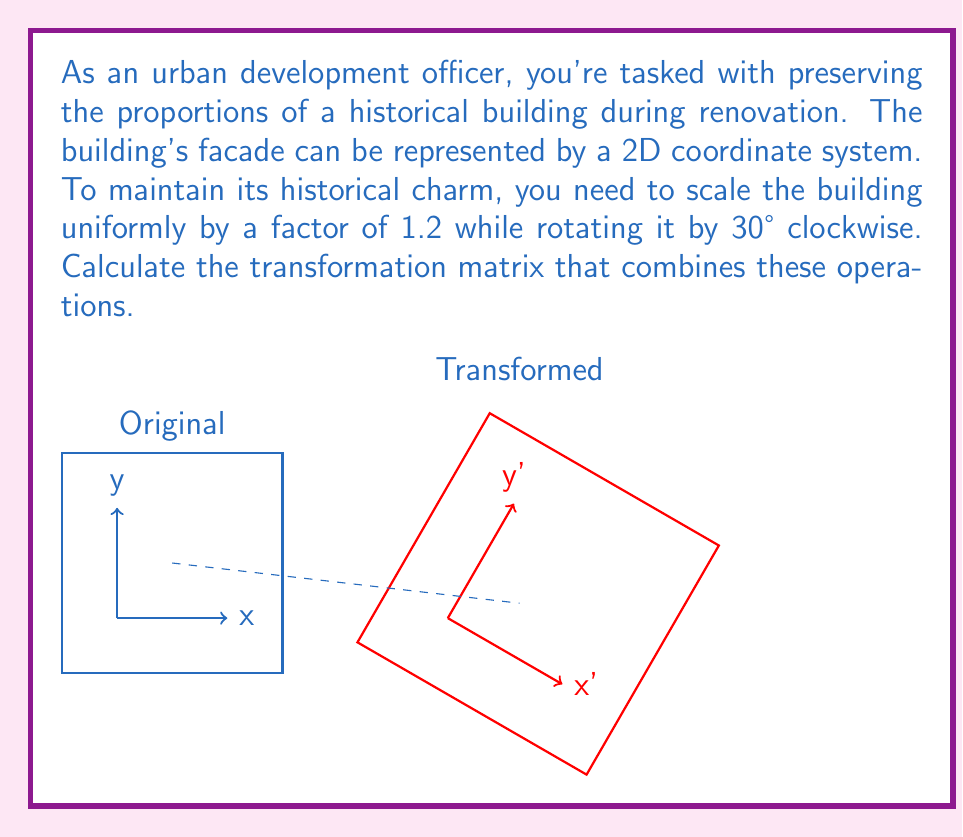Provide a solution to this math problem. To solve this problem, we need to combine two transformations: scaling and rotation. Let's approach this step-by-step:

1) First, let's recall the transformation matrices for scaling and rotation:

   Scaling matrix (by factor k): 
   $$S = \begin{pmatrix} k & 0 \\ 0 & k \end{pmatrix}$$

   Rotation matrix (by angle θ clockwise):
   $$R = \begin{pmatrix} \cos\theta & \sin\theta \\ -\sin\theta & \cos\theta \end{pmatrix}$$

2) In our case, k = 1.2 and θ = 30° = π/6 radians.

3) Let's calculate the scaling matrix:
   $$S = \begin{pmatrix} 1.2 & 0 \\ 0 & 1.2 \end{pmatrix}$$

4) Now, let's calculate the rotation matrix:
   $$R = \begin{pmatrix} \cos(π/6) & \sin(π/6) \\ -\sin(π/6) & \cos(π/6) \end{pmatrix}
   = \begin{pmatrix} \sqrt{3}/2 & 1/2 \\ -1/2 & \sqrt{3}/2 \end{pmatrix}$$

5) To combine these transformations, we multiply the matrices in the order: rotation first, then scaling. The resulting transformation matrix T is:

   $$T = S \cdot R = \begin{pmatrix} 1.2 & 0 \\ 0 & 1.2 \end{pmatrix} \cdot \begin{pmatrix} \sqrt{3}/2 & 1/2 \\ -1/2 & \sqrt{3}/2 \end{pmatrix}$$

6) Multiplying these matrices:

   $$T = \begin{pmatrix} 1.2\sqrt{3}/2 & 1.2/2 \\ -1.2/2 & 1.2\sqrt{3}/2 \end{pmatrix}
   = \begin{pmatrix} 1.039 & 0.6 \\ -0.6 & 1.039 \end{pmatrix}$$

This final matrix T represents the combined transformation that scales the building by 1.2 and rotates it 30° clockwise, preserving its proportions.
Answer: $$T = \begin{pmatrix} 1.039 & 0.6 \\ -0.6 & 1.039 \end{pmatrix}$$ 